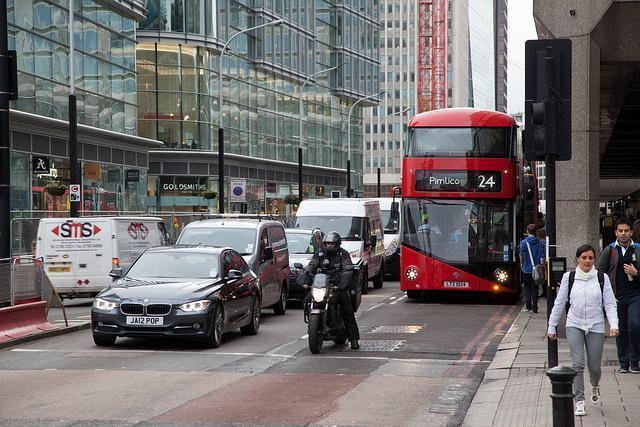What area of London does the bus go to?
Choose the correct response and explain in the format: 'Answer: answer
Rationale: rationale.'
Options: South, west, central, north. Answer: central.
Rationale: The area is central. 